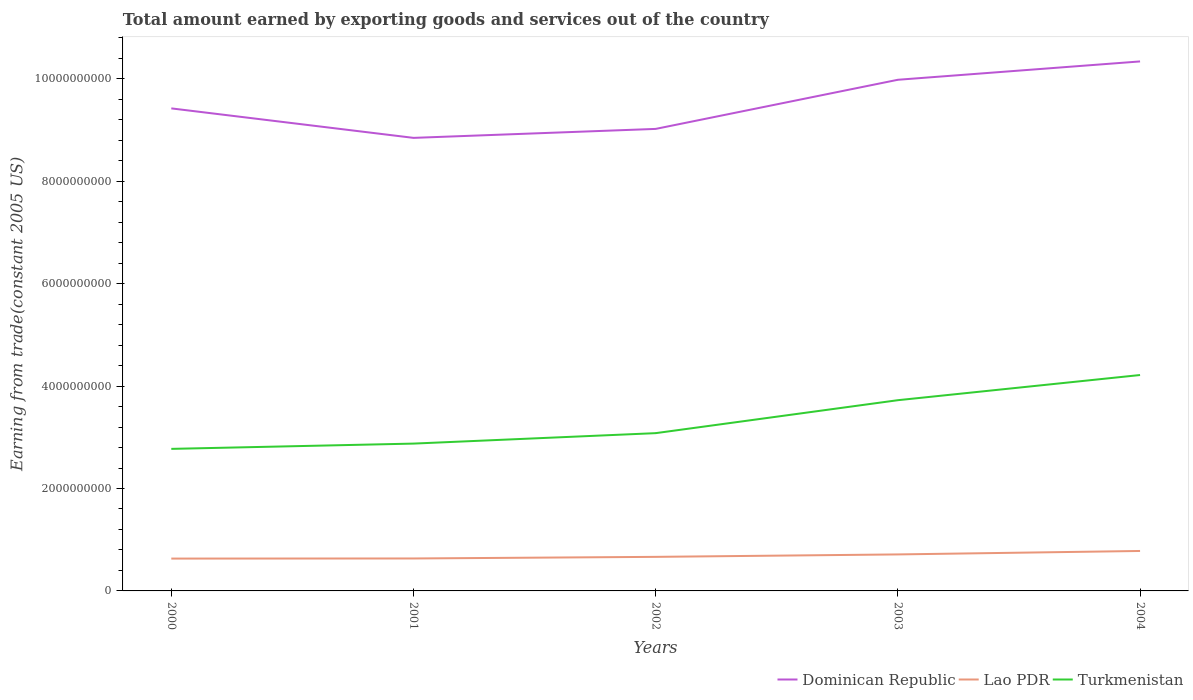Is the number of lines equal to the number of legend labels?
Offer a terse response. Yes. Across all years, what is the maximum total amount earned by exporting goods and services in Turkmenistan?
Keep it short and to the point. 2.77e+09. In which year was the total amount earned by exporting goods and services in Turkmenistan maximum?
Make the answer very short. 2000. What is the total total amount earned by exporting goods and services in Lao PDR in the graph?
Your response must be concise. -3.15e+07. What is the difference between the highest and the second highest total amount earned by exporting goods and services in Turkmenistan?
Keep it short and to the point. 1.44e+09. Does the graph contain any zero values?
Your answer should be compact. No. What is the title of the graph?
Your answer should be compact. Total amount earned by exporting goods and services out of the country. What is the label or title of the X-axis?
Give a very brief answer. Years. What is the label or title of the Y-axis?
Provide a short and direct response. Earning from trade(constant 2005 US). What is the Earning from trade(constant 2005 US) in Dominican Republic in 2000?
Provide a succinct answer. 9.42e+09. What is the Earning from trade(constant 2005 US) in Lao PDR in 2000?
Give a very brief answer. 6.32e+08. What is the Earning from trade(constant 2005 US) in Turkmenistan in 2000?
Provide a short and direct response. 2.77e+09. What is the Earning from trade(constant 2005 US) of Dominican Republic in 2001?
Give a very brief answer. 8.85e+09. What is the Earning from trade(constant 2005 US) of Lao PDR in 2001?
Offer a terse response. 6.34e+08. What is the Earning from trade(constant 2005 US) in Turkmenistan in 2001?
Offer a very short reply. 2.88e+09. What is the Earning from trade(constant 2005 US) in Dominican Republic in 2002?
Your response must be concise. 9.02e+09. What is the Earning from trade(constant 2005 US) in Lao PDR in 2002?
Make the answer very short. 6.65e+08. What is the Earning from trade(constant 2005 US) of Turkmenistan in 2002?
Ensure brevity in your answer.  3.08e+09. What is the Earning from trade(constant 2005 US) of Dominican Republic in 2003?
Offer a terse response. 9.98e+09. What is the Earning from trade(constant 2005 US) in Lao PDR in 2003?
Ensure brevity in your answer.  7.13e+08. What is the Earning from trade(constant 2005 US) of Turkmenistan in 2003?
Your response must be concise. 3.72e+09. What is the Earning from trade(constant 2005 US) in Dominican Republic in 2004?
Give a very brief answer. 1.03e+1. What is the Earning from trade(constant 2005 US) in Lao PDR in 2004?
Provide a succinct answer. 7.80e+08. What is the Earning from trade(constant 2005 US) in Turkmenistan in 2004?
Your answer should be compact. 4.22e+09. Across all years, what is the maximum Earning from trade(constant 2005 US) of Dominican Republic?
Your response must be concise. 1.03e+1. Across all years, what is the maximum Earning from trade(constant 2005 US) in Lao PDR?
Ensure brevity in your answer.  7.80e+08. Across all years, what is the maximum Earning from trade(constant 2005 US) in Turkmenistan?
Make the answer very short. 4.22e+09. Across all years, what is the minimum Earning from trade(constant 2005 US) in Dominican Republic?
Provide a short and direct response. 8.85e+09. Across all years, what is the minimum Earning from trade(constant 2005 US) of Lao PDR?
Provide a succinct answer. 6.32e+08. Across all years, what is the minimum Earning from trade(constant 2005 US) of Turkmenistan?
Offer a terse response. 2.77e+09. What is the total Earning from trade(constant 2005 US) in Dominican Republic in the graph?
Ensure brevity in your answer.  4.76e+1. What is the total Earning from trade(constant 2005 US) of Lao PDR in the graph?
Give a very brief answer. 3.42e+09. What is the total Earning from trade(constant 2005 US) of Turkmenistan in the graph?
Ensure brevity in your answer.  1.67e+1. What is the difference between the Earning from trade(constant 2005 US) in Dominican Republic in 2000 and that in 2001?
Your answer should be very brief. 5.76e+08. What is the difference between the Earning from trade(constant 2005 US) in Lao PDR in 2000 and that in 2001?
Offer a terse response. -2.19e+06. What is the difference between the Earning from trade(constant 2005 US) of Turkmenistan in 2000 and that in 2001?
Offer a very short reply. -1.03e+08. What is the difference between the Earning from trade(constant 2005 US) of Dominican Republic in 2000 and that in 2002?
Offer a very short reply. 4.01e+08. What is the difference between the Earning from trade(constant 2005 US) of Lao PDR in 2000 and that in 2002?
Make the answer very short. -3.37e+07. What is the difference between the Earning from trade(constant 2005 US) of Turkmenistan in 2000 and that in 2002?
Provide a succinct answer. -3.07e+08. What is the difference between the Earning from trade(constant 2005 US) in Dominican Republic in 2000 and that in 2003?
Provide a short and direct response. -5.59e+08. What is the difference between the Earning from trade(constant 2005 US) in Lao PDR in 2000 and that in 2003?
Provide a short and direct response. -8.13e+07. What is the difference between the Earning from trade(constant 2005 US) in Turkmenistan in 2000 and that in 2003?
Ensure brevity in your answer.  -9.50e+08. What is the difference between the Earning from trade(constant 2005 US) of Dominican Republic in 2000 and that in 2004?
Keep it short and to the point. -9.17e+08. What is the difference between the Earning from trade(constant 2005 US) in Lao PDR in 2000 and that in 2004?
Give a very brief answer. -1.49e+08. What is the difference between the Earning from trade(constant 2005 US) in Turkmenistan in 2000 and that in 2004?
Offer a terse response. -1.44e+09. What is the difference between the Earning from trade(constant 2005 US) of Dominican Republic in 2001 and that in 2002?
Give a very brief answer. -1.75e+08. What is the difference between the Earning from trade(constant 2005 US) in Lao PDR in 2001 and that in 2002?
Provide a succinct answer. -3.15e+07. What is the difference between the Earning from trade(constant 2005 US) of Turkmenistan in 2001 and that in 2002?
Provide a short and direct response. -2.04e+08. What is the difference between the Earning from trade(constant 2005 US) in Dominican Republic in 2001 and that in 2003?
Keep it short and to the point. -1.13e+09. What is the difference between the Earning from trade(constant 2005 US) in Lao PDR in 2001 and that in 2003?
Your answer should be very brief. -7.91e+07. What is the difference between the Earning from trade(constant 2005 US) of Turkmenistan in 2001 and that in 2003?
Your answer should be compact. -8.48e+08. What is the difference between the Earning from trade(constant 2005 US) in Dominican Republic in 2001 and that in 2004?
Ensure brevity in your answer.  -1.49e+09. What is the difference between the Earning from trade(constant 2005 US) in Lao PDR in 2001 and that in 2004?
Provide a short and direct response. -1.47e+08. What is the difference between the Earning from trade(constant 2005 US) in Turkmenistan in 2001 and that in 2004?
Ensure brevity in your answer.  -1.34e+09. What is the difference between the Earning from trade(constant 2005 US) in Dominican Republic in 2002 and that in 2003?
Provide a succinct answer. -9.59e+08. What is the difference between the Earning from trade(constant 2005 US) of Lao PDR in 2002 and that in 2003?
Offer a terse response. -4.76e+07. What is the difference between the Earning from trade(constant 2005 US) in Turkmenistan in 2002 and that in 2003?
Keep it short and to the point. -6.44e+08. What is the difference between the Earning from trade(constant 2005 US) of Dominican Republic in 2002 and that in 2004?
Ensure brevity in your answer.  -1.32e+09. What is the difference between the Earning from trade(constant 2005 US) of Lao PDR in 2002 and that in 2004?
Keep it short and to the point. -1.15e+08. What is the difference between the Earning from trade(constant 2005 US) in Turkmenistan in 2002 and that in 2004?
Keep it short and to the point. -1.14e+09. What is the difference between the Earning from trade(constant 2005 US) in Dominican Republic in 2003 and that in 2004?
Your response must be concise. -3.58e+08. What is the difference between the Earning from trade(constant 2005 US) in Lao PDR in 2003 and that in 2004?
Give a very brief answer. -6.75e+07. What is the difference between the Earning from trade(constant 2005 US) in Turkmenistan in 2003 and that in 2004?
Keep it short and to the point. -4.92e+08. What is the difference between the Earning from trade(constant 2005 US) in Dominican Republic in 2000 and the Earning from trade(constant 2005 US) in Lao PDR in 2001?
Ensure brevity in your answer.  8.79e+09. What is the difference between the Earning from trade(constant 2005 US) in Dominican Republic in 2000 and the Earning from trade(constant 2005 US) in Turkmenistan in 2001?
Give a very brief answer. 6.55e+09. What is the difference between the Earning from trade(constant 2005 US) of Lao PDR in 2000 and the Earning from trade(constant 2005 US) of Turkmenistan in 2001?
Keep it short and to the point. -2.25e+09. What is the difference between the Earning from trade(constant 2005 US) in Dominican Republic in 2000 and the Earning from trade(constant 2005 US) in Lao PDR in 2002?
Offer a terse response. 8.76e+09. What is the difference between the Earning from trade(constant 2005 US) of Dominican Republic in 2000 and the Earning from trade(constant 2005 US) of Turkmenistan in 2002?
Your answer should be very brief. 6.34e+09. What is the difference between the Earning from trade(constant 2005 US) of Lao PDR in 2000 and the Earning from trade(constant 2005 US) of Turkmenistan in 2002?
Your answer should be compact. -2.45e+09. What is the difference between the Earning from trade(constant 2005 US) of Dominican Republic in 2000 and the Earning from trade(constant 2005 US) of Lao PDR in 2003?
Your response must be concise. 8.71e+09. What is the difference between the Earning from trade(constant 2005 US) in Dominican Republic in 2000 and the Earning from trade(constant 2005 US) in Turkmenistan in 2003?
Make the answer very short. 5.70e+09. What is the difference between the Earning from trade(constant 2005 US) of Lao PDR in 2000 and the Earning from trade(constant 2005 US) of Turkmenistan in 2003?
Your response must be concise. -3.09e+09. What is the difference between the Earning from trade(constant 2005 US) of Dominican Republic in 2000 and the Earning from trade(constant 2005 US) of Lao PDR in 2004?
Your response must be concise. 8.64e+09. What is the difference between the Earning from trade(constant 2005 US) of Dominican Republic in 2000 and the Earning from trade(constant 2005 US) of Turkmenistan in 2004?
Provide a succinct answer. 5.21e+09. What is the difference between the Earning from trade(constant 2005 US) of Lao PDR in 2000 and the Earning from trade(constant 2005 US) of Turkmenistan in 2004?
Your answer should be compact. -3.58e+09. What is the difference between the Earning from trade(constant 2005 US) in Dominican Republic in 2001 and the Earning from trade(constant 2005 US) in Lao PDR in 2002?
Give a very brief answer. 8.18e+09. What is the difference between the Earning from trade(constant 2005 US) of Dominican Republic in 2001 and the Earning from trade(constant 2005 US) of Turkmenistan in 2002?
Ensure brevity in your answer.  5.77e+09. What is the difference between the Earning from trade(constant 2005 US) of Lao PDR in 2001 and the Earning from trade(constant 2005 US) of Turkmenistan in 2002?
Offer a very short reply. -2.45e+09. What is the difference between the Earning from trade(constant 2005 US) in Dominican Republic in 2001 and the Earning from trade(constant 2005 US) in Lao PDR in 2003?
Offer a very short reply. 8.13e+09. What is the difference between the Earning from trade(constant 2005 US) of Dominican Republic in 2001 and the Earning from trade(constant 2005 US) of Turkmenistan in 2003?
Your response must be concise. 5.12e+09. What is the difference between the Earning from trade(constant 2005 US) of Lao PDR in 2001 and the Earning from trade(constant 2005 US) of Turkmenistan in 2003?
Keep it short and to the point. -3.09e+09. What is the difference between the Earning from trade(constant 2005 US) in Dominican Republic in 2001 and the Earning from trade(constant 2005 US) in Lao PDR in 2004?
Your answer should be compact. 8.07e+09. What is the difference between the Earning from trade(constant 2005 US) in Dominican Republic in 2001 and the Earning from trade(constant 2005 US) in Turkmenistan in 2004?
Your answer should be compact. 4.63e+09. What is the difference between the Earning from trade(constant 2005 US) in Lao PDR in 2001 and the Earning from trade(constant 2005 US) in Turkmenistan in 2004?
Keep it short and to the point. -3.58e+09. What is the difference between the Earning from trade(constant 2005 US) of Dominican Republic in 2002 and the Earning from trade(constant 2005 US) of Lao PDR in 2003?
Offer a terse response. 8.31e+09. What is the difference between the Earning from trade(constant 2005 US) in Dominican Republic in 2002 and the Earning from trade(constant 2005 US) in Turkmenistan in 2003?
Your answer should be very brief. 5.30e+09. What is the difference between the Earning from trade(constant 2005 US) of Lao PDR in 2002 and the Earning from trade(constant 2005 US) of Turkmenistan in 2003?
Provide a succinct answer. -3.06e+09. What is the difference between the Earning from trade(constant 2005 US) of Dominican Republic in 2002 and the Earning from trade(constant 2005 US) of Lao PDR in 2004?
Keep it short and to the point. 8.24e+09. What is the difference between the Earning from trade(constant 2005 US) in Dominican Republic in 2002 and the Earning from trade(constant 2005 US) in Turkmenistan in 2004?
Keep it short and to the point. 4.81e+09. What is the difference between the Earning from trade(constant 2005 US) in Lao PDR in 2002 and the Earning from trade(constant 2005 US) in Turkmenistan in 2004?
Provide a succinct answer. -3.55e+09. What is the difference between the Earning from trade(constant 2005 US) of Dominican Republic in 2003 and the Earning from trade(constant 2005 US) of Lao PDR in 2004?
Provide a short and direct response. 9.20e+09. What is the difference between the Earning from trade(constant 2005 US) of Dominican Republic in 2003 and the Earning from trade(constant 2005 US) of Turkmenistan in 2004?
Your response must be concise. 5.77e+09. What is the difference between the Earning from trade(constant 2005 US) of Lao PDR in 2003 and the Earning from trade(constant 2005 US) of Turkmenistan in 2004?
Your response must be concise. -3.50e+09. What is the average Earning from trade(constant 2005 US) in Dominican Republic per year?
Your answer should be compact. 9.52e+09. What is the average Earning from trade(constant 2005 US) of Lao PDR per year?
Your response must be concise. 6.85e+08. What is the average Earning from trade(constant 2005 US) in Turkmenistan per year?
Make the answer very short. 3.33e+09. In the year 2000, what is the difference between the Earning from trade(constant 2005 US) of Dominican Republic and Earning from trade(constant 2005 US) of Lao PDR?
Provide a succinct answer. 8.79e+09. In the year 2000, what is the difference between the Earning from trade(constant 2005 US) in Dominican Republic and Earning from trade(constant 2005 US) in Turkmenistan?
Your response must be concise. 6.65e+09. In the year 2000, what is the difference between the Earning from trade(constant 2005 US) in Lao PDR and Earning from trade(constant 2005 US) in Turkmenistan?
Ensure brevity in your answer.  -2.14e+09. In the year 2001, what is the difference between the Earning from trade(constant 2005 US) in Dominican Republic and Earning from trade(constant 2005 US) in Lao PDR?
Provide a short and direct response. 8.21e+09. In the year 2001, what is the difference between the Earning from trade(constant 2005 US) of Dominican Republic and Earning from trade(constant 2005 US) of Turkmenistan?
Provide a succinct answer. 5.97e+09. In the year 2001, what is the difference between the Earning from trade(constant 2005 US) of Lao PDR and Earning from trade(constant 2005 US) of Turkmenistan?
Keep it short and to the point. -2.24e+09. In the year 2002, what is the difference between the Earning from trade(constant 2005 US) of Dominican Republic and Earning from trade(constant 2005 US) of Lao PDR?
Provide a succinct answer. 8.36e+09. In the year 2002, what is the difference between the Earning from trade(constant 2005 US) in Dominican Republic and Earning from trade(constant 2005 US) in Turkmenistan?
Give a very brief answer. 5.94e+09. In the year 2002, what is the difference between the Earning from trade(constant 2005 US) in Lao PDR and Earning from trade(constant 2005 US) in Turkmenistan?
Provide a short and direct response. -2.42e+09. In the year 2003, what is the difference between the Earning from trade(constant 2005 US) in Dominican Republic and Earning from trade(constant 2005 US) in Lao PDR?
Make the answer very short. 9.27e+09. In the year 2003, what is the difference between the Earning from trade(constant 2005 US) of Dominican Republic and Earning from trade(constant 2005 US) of Turkmenistan?
Ensure brevity in your answer.  6.26e+09. In the year 2003, what is the difference between the Earning from trade(constant 2005 US) in Lao PDR and Earning from trade(constant 2005 US) in Turkmenistan?
Offer a very short reply. -3.01e+09. In the year 2004, what is the difference between the Earning from trade(constant 2005 US) in Dominican Republic and Earning from trade(constant 2005 US) in Lao PDR?
Your answer should be compact. 9.56e+09. In the year 2004, what is the difference between the Earning from trade(constant 2005 US) of Dominican Republic and Earning from trade(constant 2005 US) of Turkmenistan?
Offer a very short reply. 6.12e+09. In the year 2004, what is the difference between the Earning from trade(constant 2005 US) of Lao PDR and Earning from trade(constant 2005 US) of Turkmenistan?
Offer a terse response. -3.44e+09. What is the ratio of the Earning from trade(constant 2005 US) in Dominican Republic in 2000 to that in 2001?
Ensure brevity in your answer.  1.07. What is the ratio of the Earning from trade(constant 2005 US) of Lao PDR in 2000 to that in 2001?
Provide a succinct answer. 1. What is the ratio of the Earning from trade(constant 2005 US) in Turkmenistan in 2000 to that in 2001?
Give a very brief answer. 0.96. What is the ratio of the Earning from trade(constant 2005 US) of Dominican Republic in 2000 to that in 2002?
Provide a succinct answer. 1.04. What is the ratio of the Earning from trade(constant 2005 US) in Lao PDR in 2000 to that in 2002?
Give a very brief answer. 0.95. What is the ratio of the Earning from trade(constant 2005 US) of Turkmenistan in 2000 to that in 2002?
Ensure brevity in your answer.  0.9. What is the ratio of the Earning from trade(constant 2005 US) in Dominican Republic in 2000 to that in 2003?
Provide a short and direct response. 0.94. What is the ratio of the Earning from trade(constant 2005 US) of Lao PDR in 2000 to that in 2003?
Offer a terse response. 0.89. What is the ratio of the Earning from trade(constant 2005 US) in Turkmenistan in 2000 to that in 2003?
Your answer should be compact. 0.74. What is the ratio of the Earning from trade(constant 2005 US) of Dominican Republic in 2000 to that in 2004?
Make the answer very short. 0.91. What is the ratio of the Earning from trade(constant 2005 US) of Lao PDR in 2000 to that in 2004?
Provide a succinct answer. 0.81. What is the ratio of the Earning from trade(constant 2005 US) of Turkmenistan in 2000 to that in 2004?
Your answer should be compact. 0.66. What is the ratio of the Earning from trade(constant 2005 US) of Dominican Republic in 2001 to that in 2002?
Ensure brevity in your answer.  0.98. What is the ratio of the Earning from trade(constant 2005 US) in Lao PDR in 2001 to that in 2002?
Offer a very short reply. 0.95. What is the ratio of the Earning from trade(constant 2005 US) of Turkmenistan in 2001 to that in 2002?
Your answer should be compact. 0.93. What is the ratio of the Earning from trade(constant 2005 US) in Dominican Republic in 2001 to that in 2003?
Your response must be concise. 0.89. What is the ratio of the Earning from trade(constant 2005 US) of Lao PDR in 2001 to that in 2003?
Make the answer very short. 0.89. What is the ratio of the Earning from trade(constant 2005 US) in Turkmenistan in 2001 to that in 2003?
Provide a short and direct response. 0.77. What is the ratio of the Earning from trade(constant 2005 US) in Dominican Republic in 2001 to that in 2004?
Ensure brevity in your answer.  0.86. What is the ratio of the Earning from trade(constant 2005 US) of Lao PDR in 2001 to that in 2004?
Offer a very short reply. 0.81. What is the ratio of the Earning from trade(constant 2005 US) of Turkmenistan in 2001 to that in 2004?
Make the answer very short. 0.68. What is the ratio of the Earning from trade(constant 2005 US) of Dominican Republic in 2002 to that in 2003?
Provide a short and direct response. 0.9. What is the ratio of the Earning from trade(constant 2005 US) of Lao PDR in 2002 to that in 2003?
Make the answer very short. 0.93. What is the ratio of the Earning from trade(constant 2005 US) in Turkmenistan in 2002 to that in 2003?
Provide a short and direct response. 0.83. What is the ratio of the Earning from trade(constant 2005 US) in Dominican Republic in 2002 to that in 2004?
Keep it short and to the point. 0.87. What is the ratio of the Earning from trade(constant 2005 US) in Lao PDR in 2002 to that in 2004?
Your answer should be compact. 0.85. What is the ratio of the Earning from trade(constant 2005 US) in Turkmenistan in 2002 to that in 2004?
Offer a very short reply. 0.73. What is the ratio of the Earning from trade(constant 2005 US) in Dominican Republic in 2003 to that in 2004?
Provide a short and direct response. 0.97. What is the ratio of the Earning from trade(constant 2005 US) in Lao PDR in 2003 to that in 2004?
Your answer should be compact. 0.91. What is the ratio of the Earning from trade(constant 2005 US) in Turkmenistan in 2003 to that in 2004?
Provide a succinct answer. 0.88. What is the difference between the highest and the second highest Earning from trade(constant 2005 US) in Dominican Republic?
Keep it short and to the point. 3.58e+08. What is the difference between the highest and the second highest Earning from trade(constant 2005 US) in Lao PDR?
Make the answer very short. 6.75e+07. What is the difference between the highest and the second highest Earning from trade(constant 2005 US) in Turkmenistan?
Provide a succinct answer. 4.92e+08. What is the difference between the highest and the lowest Earning from trade(constant 2005 US) of Dominican Republic?
Your answer should be compact. 1.49e+09. What is the difference between the highest and the lowest Earning from trade(constant 2005 US) of Lao PDR?
Keep it short and to the point. 1.49e+08. What is the difference between the highest and the lowest Earning from trade(constant 2005 US) in Turkmenistan?
Offer a very short reply. 1.44e+09. 